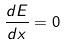<formula> <loc_0><loc_0><loc_500><loc_500>\frac { d E } { d x } = 0</formula> 